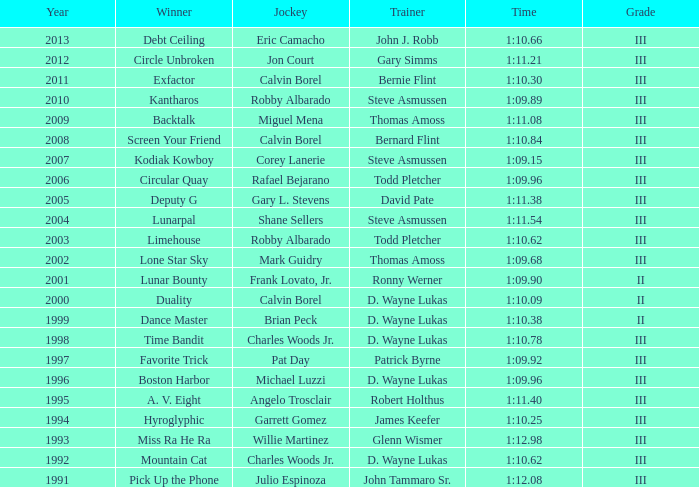Who was the winning trainer of the hyroglyphic in a year that occurred before 2010? James Keefer. 